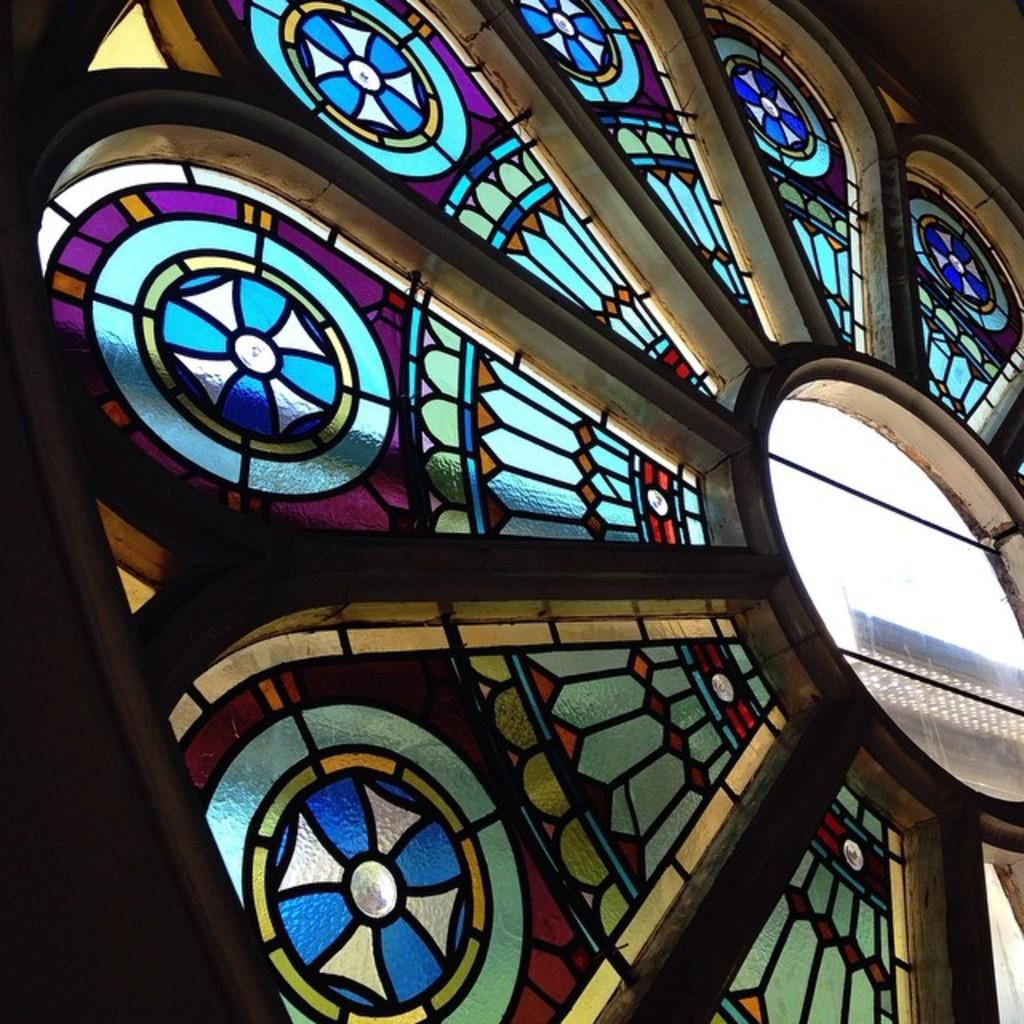What type of structure is present in the image? There is a glass window in the image. What is depicted on the window? The window has paintings on it. What is the window part of? The window is part of a flower structure. What type of protest is taking place outside the window in the image? There is no protest present in the image; it only features a glass window with paintings and is part of a flower structure. 